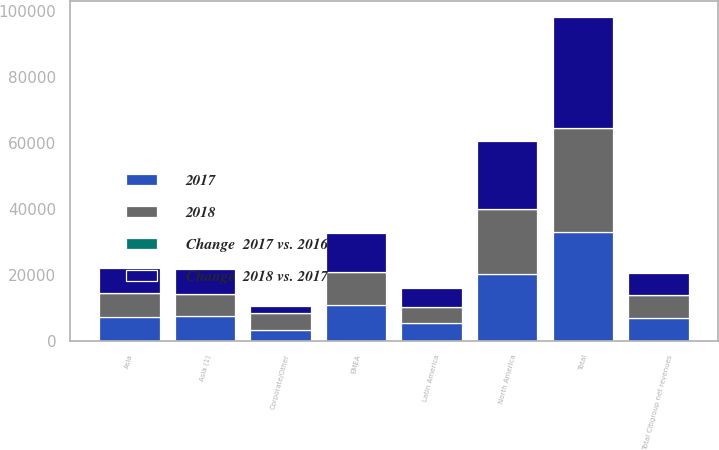Convert chart to OTSL. <chart><loc_0><loc_0><loc_500><loc_500><stacked_bar_chart><ecel><fcel>North America<fcel>Latin America<fcel>Asia (1)<fcel>Total<fcel>EMEA<fcel>Asia<fcel>Corporate/Other<fcel>Total Citigroup net revenues<nl><fcel>Change  2018 vs. 2017<fcel>20544<fcel>5760<fcel>7473<fcel>33777<fcel>11770<fcel>7806<fcel>2083<fcel>6889<nl><fcel>2017<fcel>20270<fcel>5222<fcel>7346<fcel>32838<fcel>10879<fcel>7287<fcel>3132<fcel>6889<nl><fcel>2018<fcel>19764<fcel>4971<fcel>6889<fcel>31624<fcel>10012<fcel>7036<fcel>5233<fcel>6889<nl><fcel>Change  2017 vs. 2016<fcel>1<fcel>10<fcel>2<fcel>3<fcel>8<fcel>7<fcel>33<fcel>1<nl></chart> 